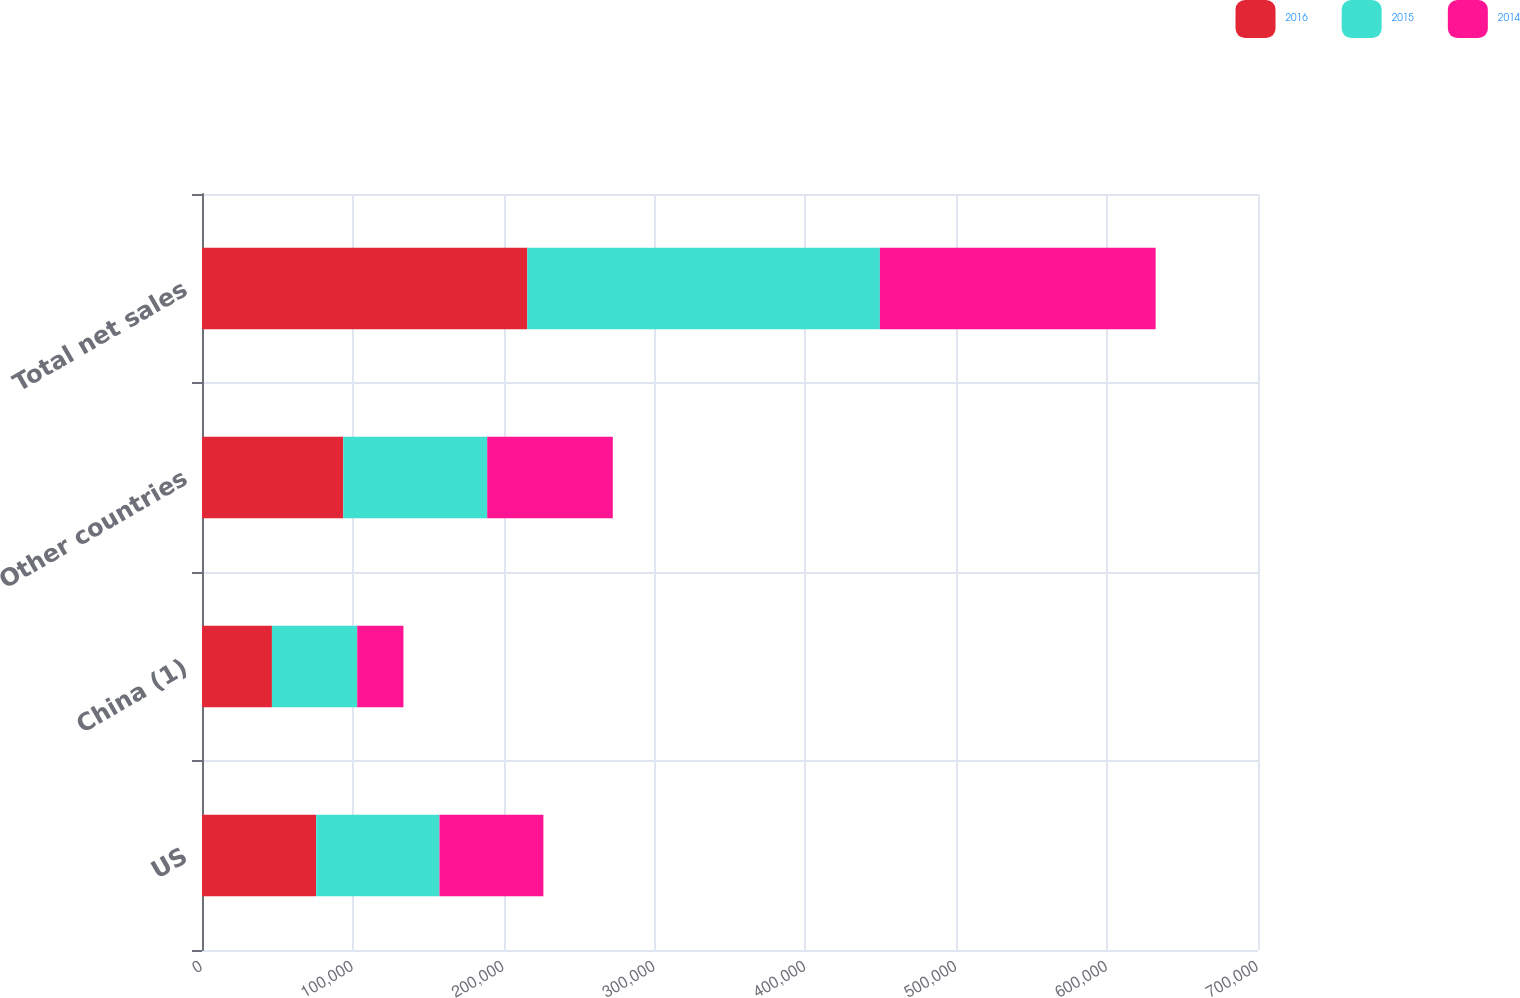<chart> <loc_0><loc_0><loc_500><loc_500><stacked_bar_chart><ecel><fcel>US<fcel>China (1)<fcel>Other countries<fcel>Total net sales<nl><fcel>2016<fcel>75667<fcel>46349<fcel>93623<fcel>215639<nl><fcel>2015<fcel>81732<fcel>56547<fcel>95436<fcel>233715<nl><fcel>2014<fcel>68909<fcel>30638<fcel>83248<fcel>182795<nl></chart> 